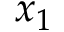Convert formula to latex. <formula><loc_0><loc_0><loc_500><loc_500>x _ { 1 }</formula> 